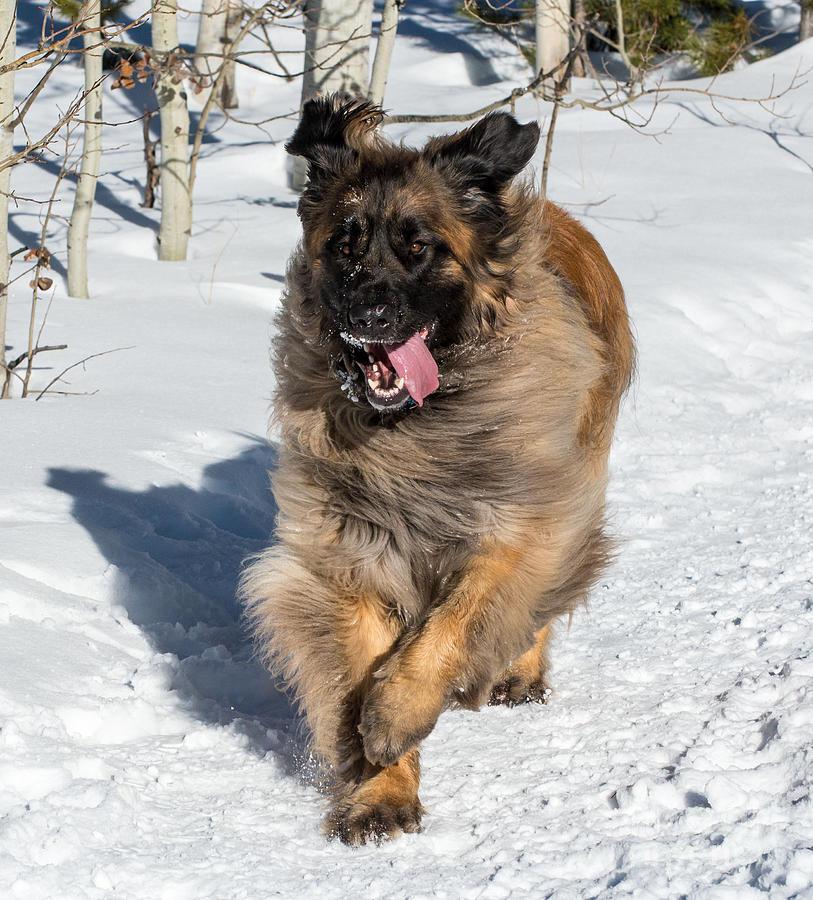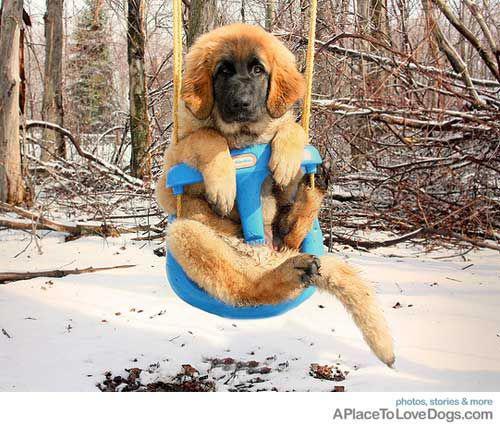The first image is the image on the left, the second image is the image on the right. For the images shown, is this caption "An image features one dog reclining with front paws extended forward." true? Answer yes or no. No. The first image is the image on the left, the second image is the image on the right. For the images shown, is this caption "The dog in the left photo has its tongue out." true? Answer yes or no. Yes. 